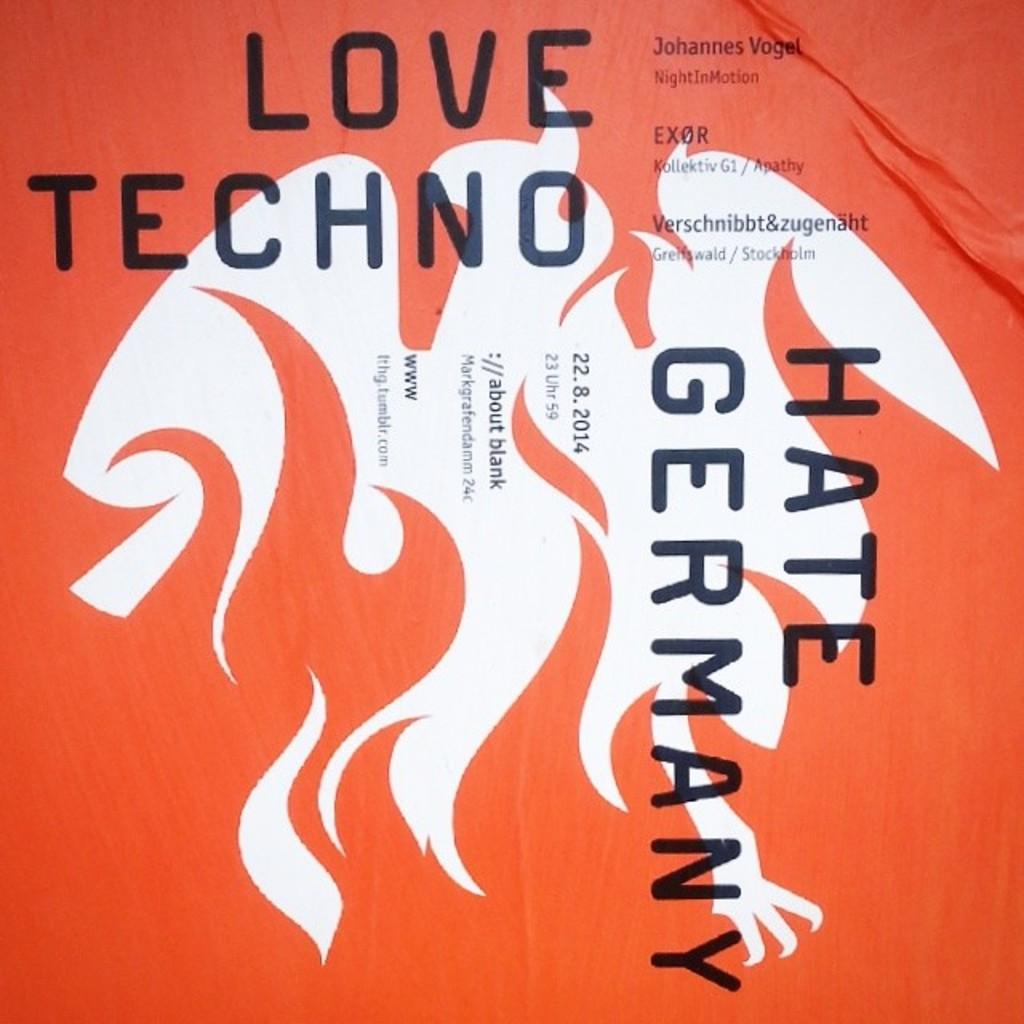<image>
Provide a brief description of the given image. A redish-orange colored techno album cover calling with Hate Germany written vertically. 